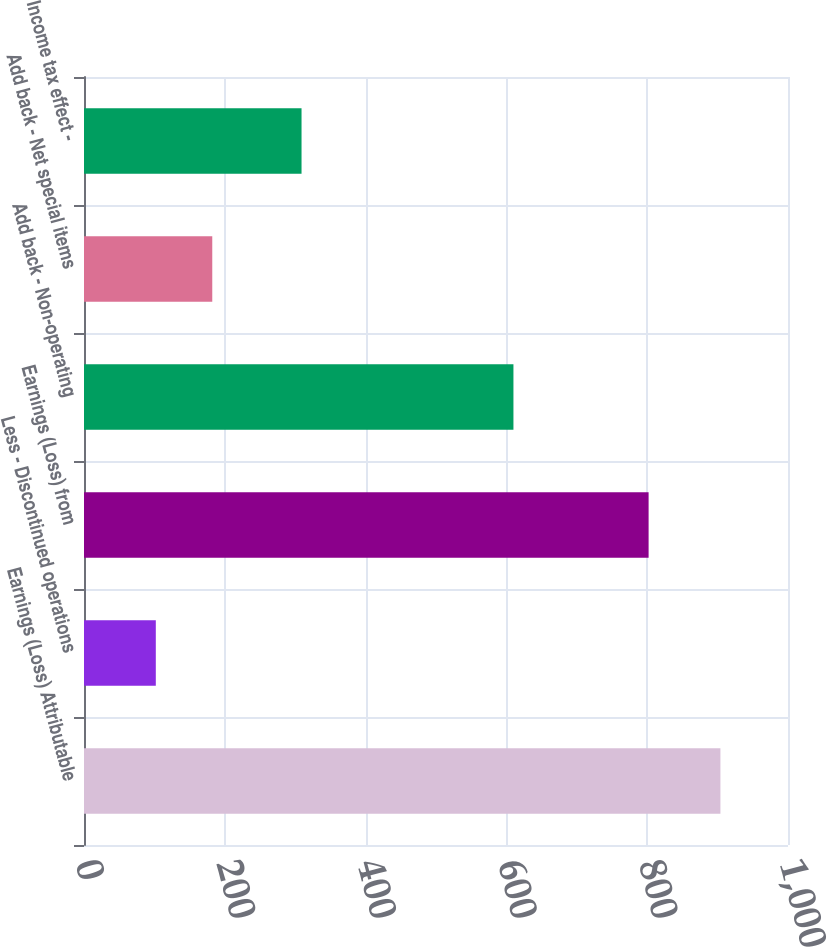Convert chart to OTSL. <chart><loc_0><loc_0><loc_500><loc_500><bar_chart><fcel>Earnings (Loss) Attributable<fcel>Less - Discontinued operations<fcel>Earnings (Loss) from<fcel>Add back - Non-operating<fcel>Add back - Net special items<fcel>Income tax effect -<nl><fcel>904<fcel>102<fcel>802<fcel>610<fcel>182.2<fcel>309<nl></chart> 